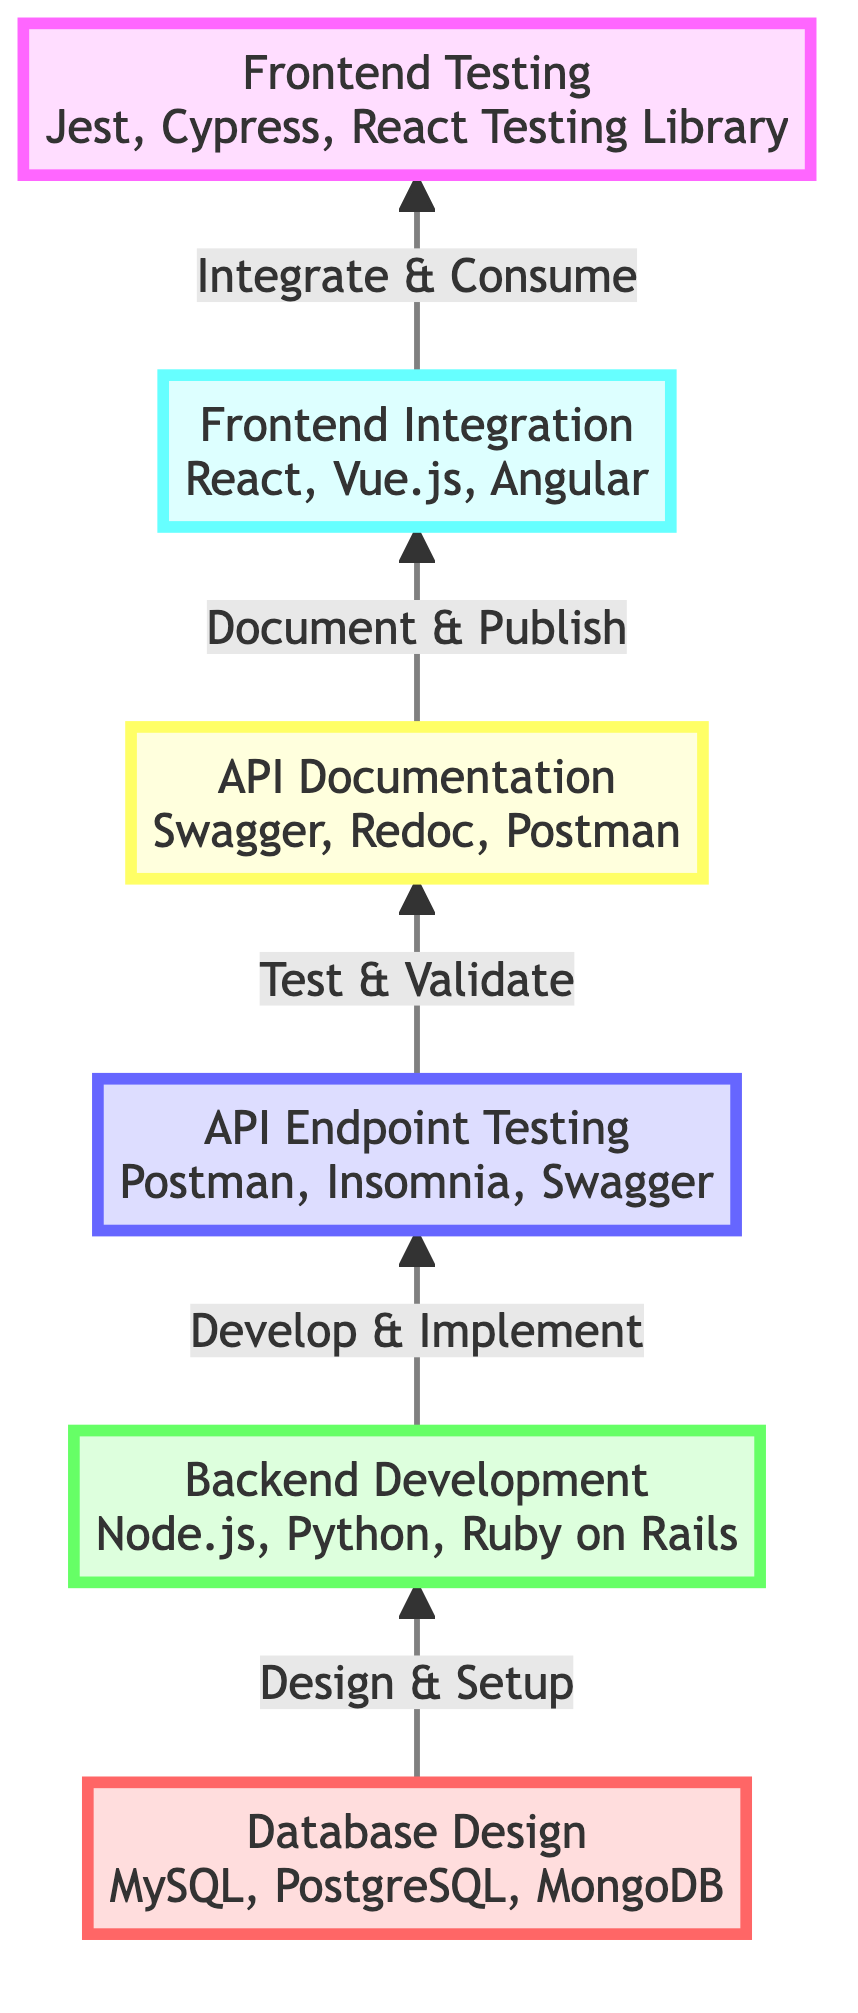What is the first step in the flow? The diagram indicates that the first step is "Database Design," which is located at the bottom of the flow chart.
Answer: Database Design How many nodes are in the diagram? The diagram contains six distinct nodes representing different stages in the API development process.
Answer: 6 What tool is used for API Endpoint Testing? According to the diagram, "Postman" is listed as one of the tools for API Endpoint Testing, which is the third stage of the flow.
Answer: Postman What is the description of Frontend Integration? The diagram states that Frontend Integration involves integrating the API endpoints into the frontend application.
Answer: Integrate the API endpoints into the frontend application Which level do you find Backend Development? In the diagram, "Backend Development" is categorized as level 2, indicating its position in the hierarchy of steps.
Answer: Level 2 What is the final task in the flow chart? The last item in the diagram is "Frontend Testing," implying that it is the final task to be completed in the API development process.
Answer: Frontend Testing How does one transition from API Documentation to Frontend Integration? The flow chart shows that the transition occurs through the connection labeled "Document & Publish," indicating the direction of the flow from documentation to integration.
Answer: Document & Publish What type of technologies are used in Backend Development? The diagram specifies that "Node.js," "Python," and "Ruby on Rails" are the technologies used in Backend Development.
Answer: Node.js, Python, Ruby on Rails 